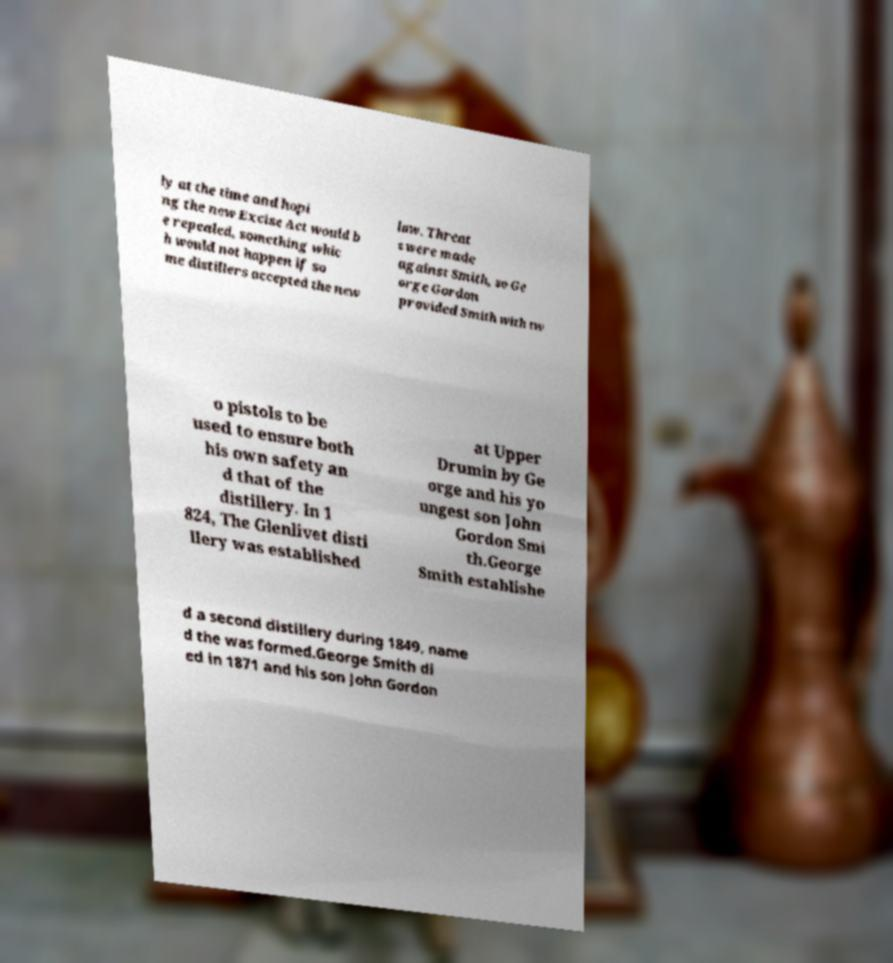There's text embedded in this image that I need extracted. Can you transcribe it verbatim? ly at the time and hopi ng the new Excise Act would b e repealed, something whic h would not happen if so me distillers accepted the new law. Threat s were made against Smith, so Ge orge Gordon provided Smith with tw o pistols to be used to ensure both his own safety an d that of the distillery. In 1 824, The Glenlivet disti llery was established at Upper Drumin by Ge orge and his yo ungest son John Gordon Smi th.George Smith establishe d a second distillery during 1849, name d the was formed.George Smith di ed in 1871 and his son John Gordon 